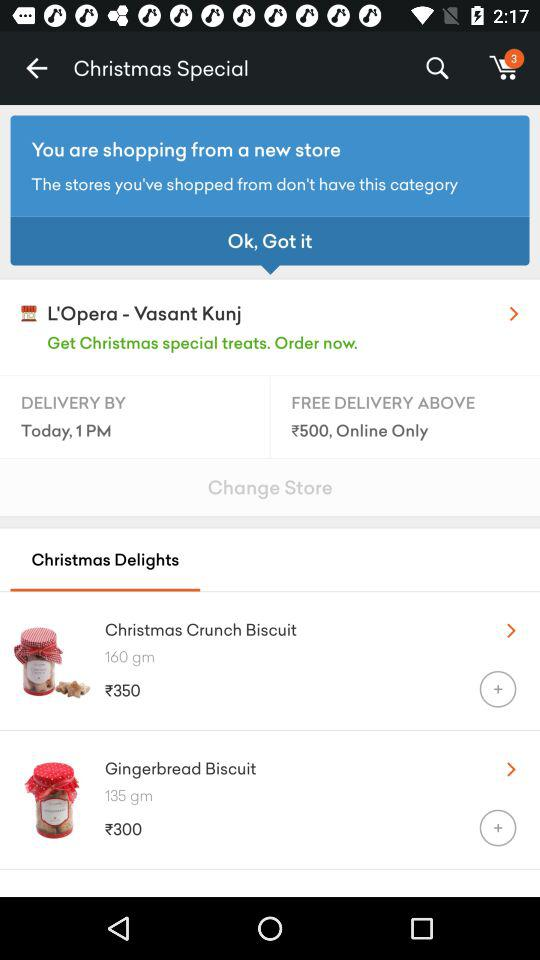What is the price of "Gingerbread Biscuit"? The price of "Gingerbread Biscuit" is ₹300. 